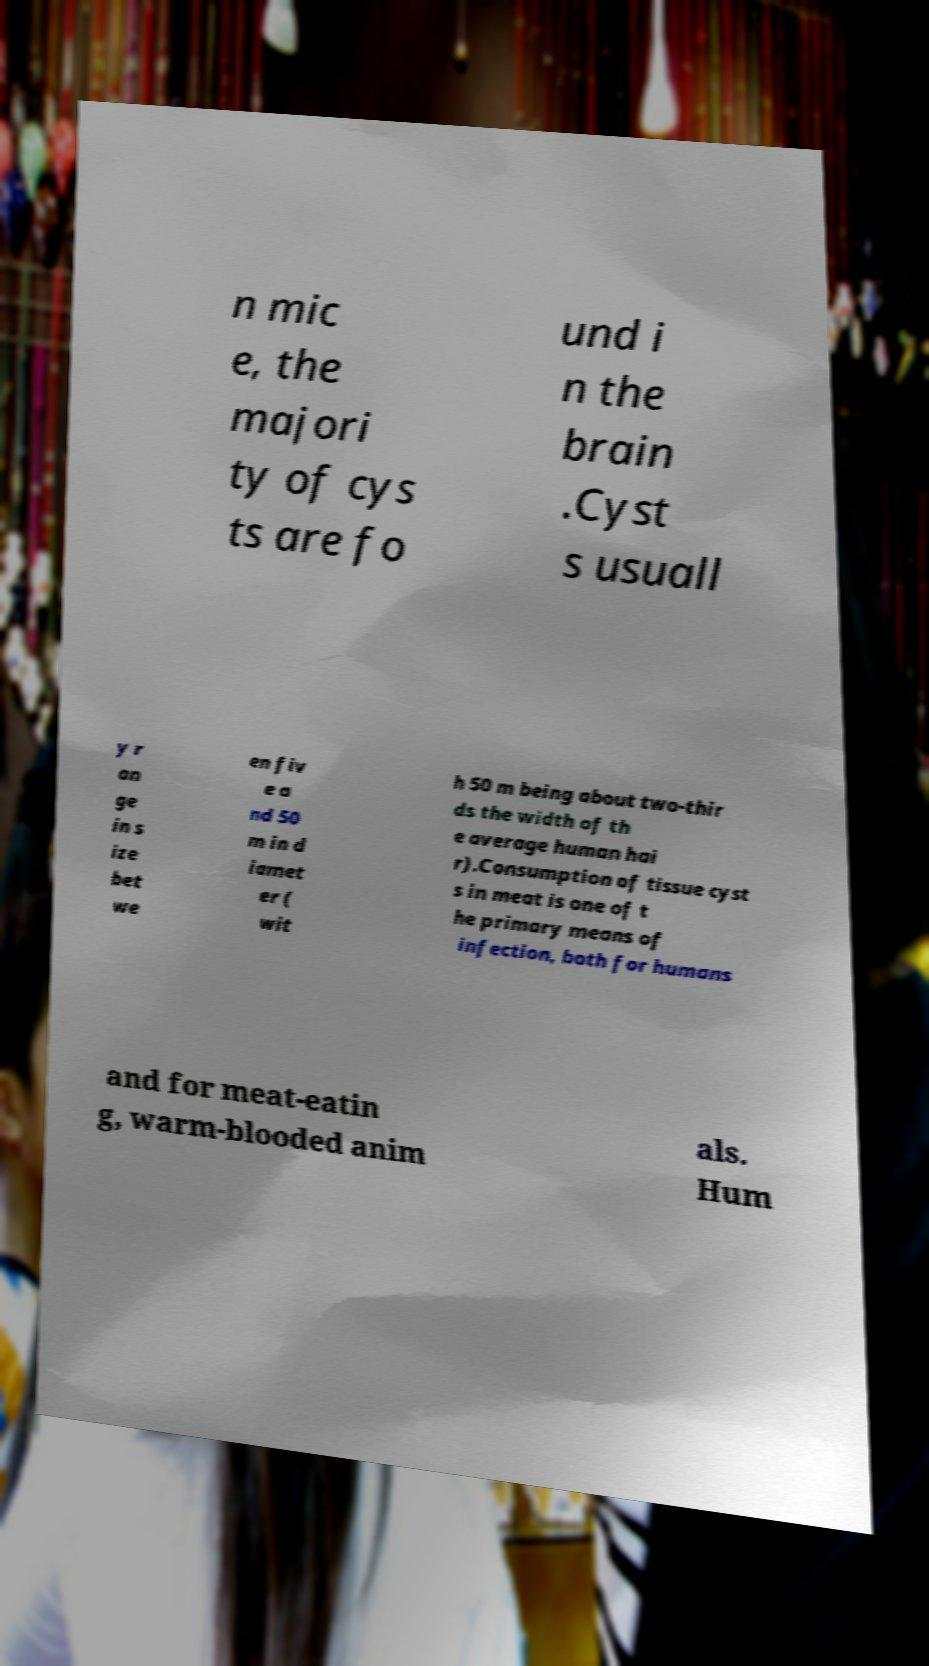Please read and relay the text visible in this image. What does it say? n mic e, the majori ty of cys ts are fo und i n the brain .Cyst s usuall y r an ge in s ize bet we en fiv e a nd 50 m in d iamet er ( wit h 50 m being about two-thir ds the width of th e average human hai r).Consumption of tissue cyst s in meat is one of t he primary means of infection, both for humans and for meat-eatin g, warm-blooded anim als. Hum 